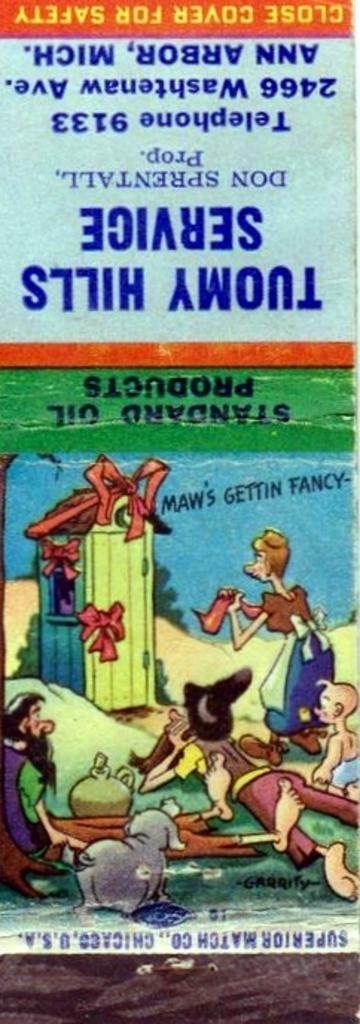<image>
Describe the image concisely. A matchbook from Tuomy Hills Service tells us to close the cover for safety. 